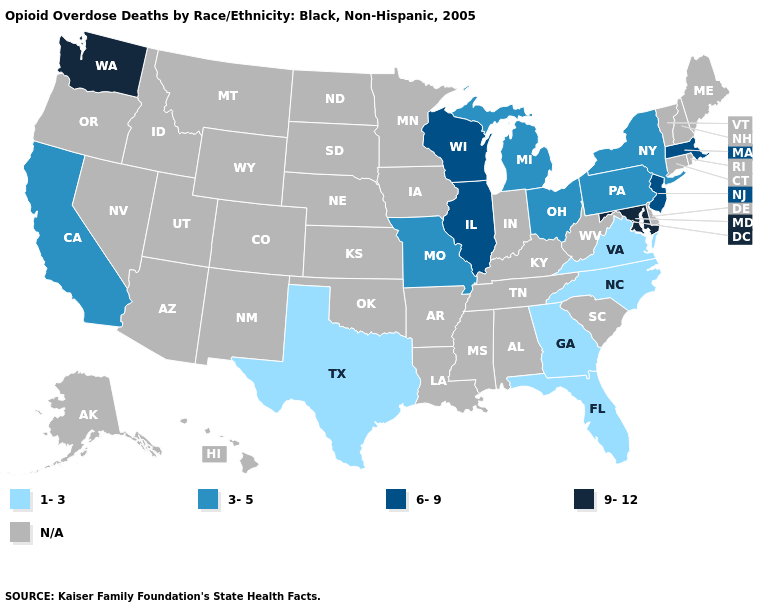Among the states that border Oklahoma , which have the highest value?
Give a very brief answer. Missouri. Which states hav the highest value in the Northeast?
Keep it brief. Massachusetts, New Jersey. Which states have the lowest value in the West?
Short answer required. California. Name the states that have a value in the range 3-5?
Quick response, please. California, Michigan, Missouri, New York, Ohio, Pennsylvania. Does the first symbol in the legend represent the smallest category?
Concise answer only. Yes. Which states have the lowest value in the Northeast?
Answer briefly. New York, Pennsylvania. Does Florida have the highest value in the USA?
Concise answer only. No. Name the states that have a value in the range 6-9?
Give a very brief answer. Illinois, Massachusetts, New Jersey, Wisconsin. Which states hav the highest value in the MidWest?
Write a very short answer. Illinois, Wisconsin. Name the states that have a value in the range 3-5?
Write a very short answer. California, Michigan, Missouri, New York, Ohio, Pennsylvania. Name the states that have a value in the range 3-5?
Be succinct. California, Michigan, Missouri, New York, Ohio, Pennsylvania. Name the states that have a value in the range N/A?
Be succinct. Alabama, Alaska, Arizona, Arkansas, Colorado, Connecticut, Delaware, Hawaii, Idaho, Indiana, Iowa, Kansas, Kentucky, Louisiana, Maine, Minnesota, Mississippi, Montana, Nebraska, Nevada, New Hampshire, New Mexico, North Dakota, Oklahoma, Oregon, Rhode Island, South Carolina, South Dakota, Tennessee, Utah, Vermont, West Virginia, Wyoming. Which states have the lowest value in the South?
Answer briefly. Florida, Georgia, North Carolina, Texas, Virginia. 